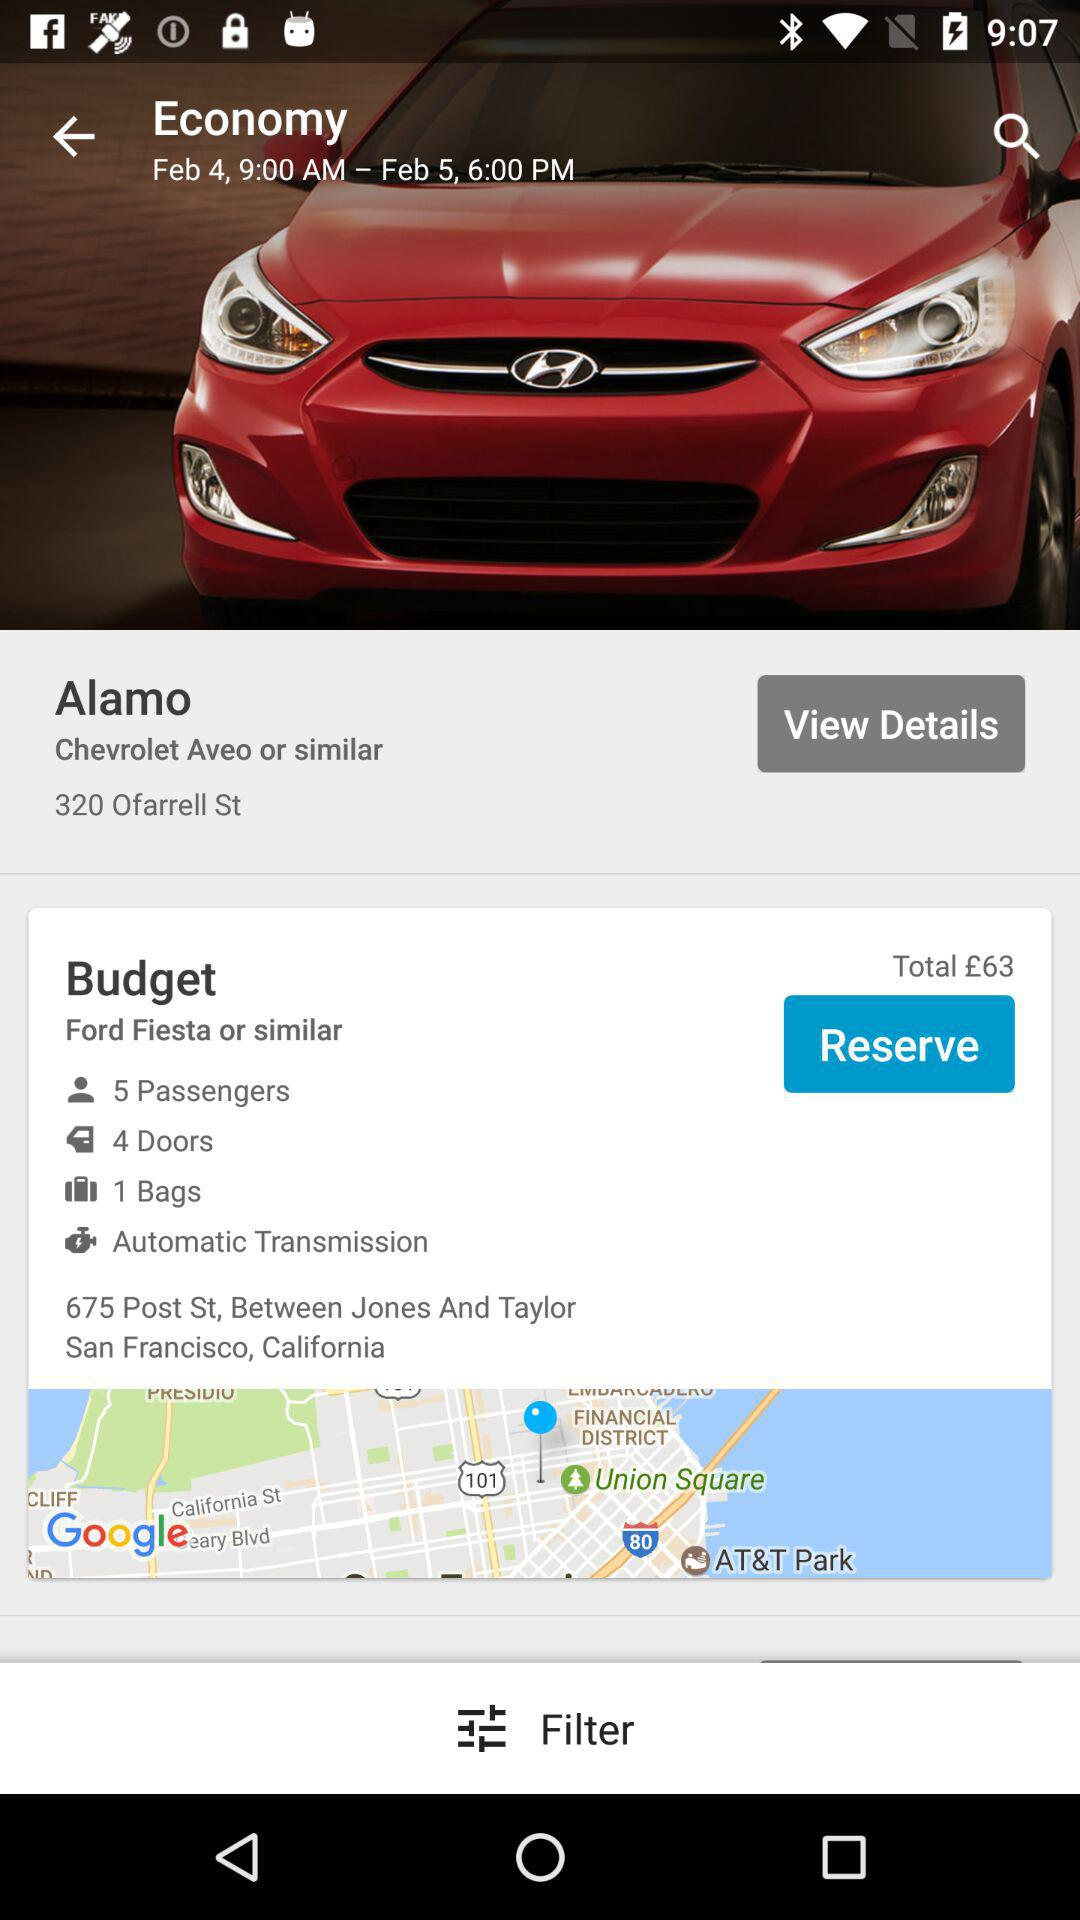What is the budget? The budget is £63. 